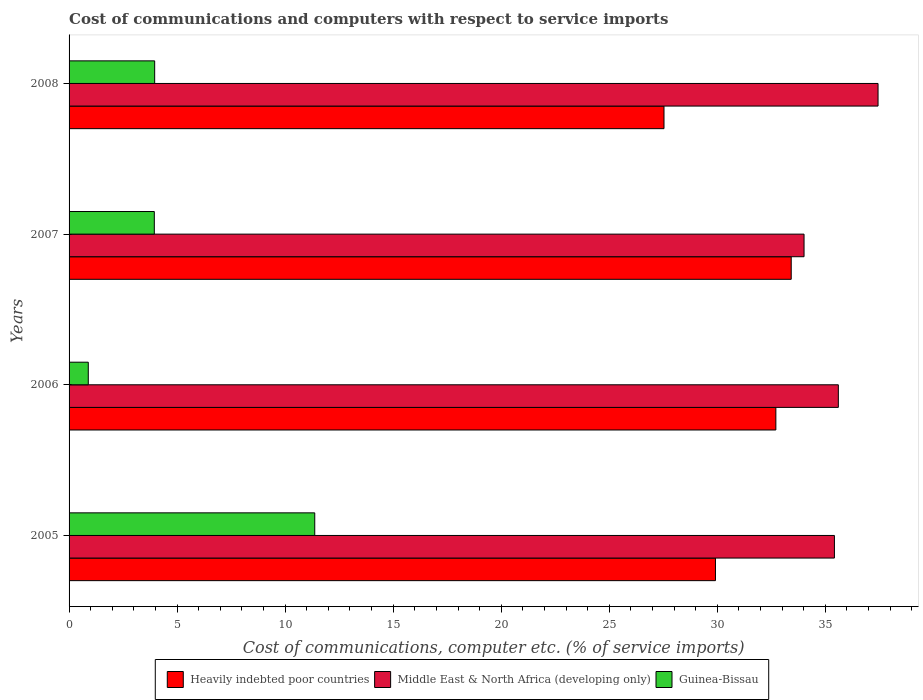How many groups of bars are there?
Provide a short and direct response. 4. Are the number of bars on each tick of the Y-axis equal?
Keep it short and to the point. Yes. How many bars are there on the 1st tick from the top?
Offer a very short reply. 3. In how many cases, is the number of bars for a given year not equal to the number of legend labels?
Provide a short and direct response. 0. What is the cost of communications and computers in Guinea-Bissau in 2007?
Your answer should be very brief. 3.95. Across all years, what is the maximum cost of communications and computers in Middle East & North Africa (developing only)?
Your answer should be very brief. 37.44. Across all years, what is the minimum cost of communications and computers in Guinea-Bissau?
Keep it short and to the point. 0.89. In which year was the cost of communications and computers in Middle East & North Africa (developing only) maximum?
Offer a terse response. 2008. What is the total cost of communications and computers in Heavily indebted poor countries in the graph?
Your response must be concise. 123.58. What is the difference between the cost of communications and computers in Middle East & North Africa (developing only) in 2006 and that in 2008?
Ensure brevity in your answer.  -1.84. What is the difference between the cost of communications and computers in Guinea-Bissau in 2006 and the cost of communications and computers in Heavily indebted poor countries in 2005?
Offer a very short reply. -29.03. What is the average cost of communications and computers in Heavily indebted poor countries per year?
Your answer should be compact. 30.89. In the year 2005, what is the difference between the cost of communications and computers in Guinea-Bissau and cost of communications and computers in Heavily indebted poor countries?
Offer a terse response. -18.54. In how many years, is the cost of communications and computers in Heavily indebted poor countries greater than 23 %?
Provide a short and direct response. 4. What is the ratio of the cost of communications and computers in Heavily indebted poor countries in 2007 to that in 2008?
Make the answer very short. 1.21. Is the cost of communications and computers in Guinea-Bissau in 2005 less than that in 2006?
Ensure brevity in your answer.  No. Is the difference between the cost of communications and computers in Guinea-Bissau in 2006 and 2008 greater than the difference between the cost of communications and computers in Heavily indebted poor countries in 2006 and 2008?
Provide a succinct answer. No. What is the difference between the highest and the second highest cost of communications and computers in Middle East & North Africa (developing only)?
Offer a terse response. 1.84. What is the difference between the highest and the lowest cost of communications and computers in Guinea-Bissau?
Provide a short and direct response. 10.48. Is the sum of the cost of communications and computers in Middle East & North Africa (developing only) in 2005 and 2006 greater than the maximum cost of communications and computers in Heavily indebted poor countries across all years?
Give a very brief answer. Yes. What does the 2nd bar from the top in 2007 represents?
Ensure brevity in your answer.  Middle East & North Africa (developing only). What does the 3rd bar from the bottom in 2005 represents?
Provide a succinct answer. Guinea-Bissau. How many bars are there?
Your answer should be very brief. 12. Are all the bars in the graph horizontal?
Provide a succinct answer. Yes. What is the difference between two consecutive major ticks on the X-axis?
Your answer should be very brief. 5. How many legend labels are there?
Give a very brief answer. 3. How are the legend labels stacked?
Give a very brief answer. Horizontal. What is the title of the graph?
Offer a very short reply. Cost of communications and computers with respect to service imports. Does "Euro area" appear as one of the legend labels in the graph?
Offer a very short reply. No. What is the label or title of the X-axis?
Make the answer very short. Cost of communications, computer etc. (% of service imports). What is the Cost of communications, computer etc. (% of service imports) of Heavily indebted poor countries in 2005?
Your answer should be very brief. 29.91. What is the Cost of communications, computer etc. (% of service imports) in Middle East & North Africa (developing only) in 2005?
Your answer should be compact. 35.42. What is the Cost of communications, computer etc. (% of service imports) in Guinea-Bissau in 2005?
Make the answer very short. 11.37. What is the Cost of communications, computer etc. (% of service imports) in Heavily indebted poor countries in 2006?
Make the answer very short. 32.71. What is the Cost of communications, computer etc. (% of service imports) in Middle East & North Africa (developing only) in 2006?
Offer a terse response. 35.6. What is the Cost of communications, computer etc. (% of service imports) of Guinea-Bissau in 2006?
Ensure brevity in your answer.  0.89. What is the Cost of communications, computer etc. (% of service imports) in Heavily indebted poor countries in 2007?
Your response must be concise. 33.42. What is the Cost of communications, computer etc. (% of service imports) in Middle East & North Africa (developing only) in 2007?
Ensure brevity in your answer.  34.01. What is the Cost of communications, computer etc. (% of service imports) of Guinea-Bissau in 2007?
Offer a very short reply. 3.95. What is the Cost of communications, computer etc. (% of service imports) in Heavily indebted poor countries in 2008?
Give a very brief answer. 27.53. What is the Cost of communications, computer etc. (% of service imports) in Middle East & North Africa (developing only) in 2008?
Your answer should be compact. 37.44. What is the Cost of communications, computer etc. (% of service imports) in Guinea-Bissau in 2008?
Provide a succinct answer. 3.96. Across all years, what is the maximum Cost of communications, computer etc. (% of service imports) in Heavily indebted poor countries?
Give a very brief answer. 33.42. Across all years, what is the maximum Cost of communications, computer etc. (% of service imports) of Middle East & North Africa (developing only)?
Your answer should be compact. 37.44. Across all years, what is the maximum Cost of communications, computer etc. (% of service imports) in Guinea-Bissau?
Your answer should be compact. 11.37. Across all years, what is the minimum Cost of communications, computer etc. (% of service imports) in Heavily indebted poor countries?
Keep it short and to the point. 27.53. Across all years, what is the minimum Cost of communications, computer etc. (% of service imports) of Middle East & North Africa (developing only)?
Your answer should be very brief. 34.01. Across all years, what is the minimum Cost of communications, computer etc. (% of service imports) of Guinea-Bissau?
Make the answer very short. 0.89. What is the total Cost of communications, computer etc. (% of service imports) in Heavily indebted poor countries in the graph?
Your answer should be very brief. 123.58. What is the total Cost of communications, computer etc. (% of service imports) of Middle East & North Africa (developing only) in the graph?
Keep it short and to the point. 142.47. What is the total Cost of communications, computer etc. (% of service imports) in Guinea-Bissau in the graph?
Provide a succinct answer. 20.17. What is the difference between the Cost of communications, computer etc. (% of service imports) of Heavily indebted poor countries in 2005 and that in 2006?
Make the answer very short. -2.79. What is the difference between the Cost of communications, computer etc. (% of service imports) of Middle East & North Africa (developing only) in 2005 and that in 2006?
Offer a very short reply. -0.18. What is the difference between the Cost of communications, computer etc. (% of service imports) of Guinea-Bissau in 2005 and that in 2006?
Ensure brevity in your answer.  10.48. What is the difference between the Cost of communications, computer etc. (% of service imports) in Heavily indebted poor countries in 2005 and that in 2007?
Your answer should be compact. -3.51. What is the difference between the Cost of communications, computer etc. (% of service imports) in Middle East & North Africa (developing only) in 2005 and that in 2007?
Give a very brief answer. 1.41. What is the difference between the Cost of communications, computer etc. (% of service imports) in Guinea-Bissau in 2005 and that in 2007?
Offer a terse response. 7.42. What is the difference between the Cost of communications, computer etc. (% of service imports) of Heavily indebted poor countries in 2005 and that in 2008?
Your answer should be very brief. 2.38. What is the difference between the Cost of communications, computer etc. (% of service imports) in Middle East & North Africa (developing only) in 2005 and that in 2008?
Your answer should be very brief. -2.02. What is the difference between the Cost of communications, computer etc. (% of service imports) of Guinea-Bissau in 2005 and that in 2008?
Offer a terse response. 7.41. What is the difference between the Cost of communications, computer etc. (% of service imports) in Heavily indebted poor countries in 2006 and that in 2007?
Keep it short and to the point. -0.71. What is the difference between the Cost of communications, computer etc. (% of service imports) in Middle East & North Africa (developing only) in 2006 and that in 2007?
Your answer should be very brief. 1.59. What is the difference between the Cost of communications, computer etc. (% of service imports) of Guinea-Bissau in 2006 and that in 2007?
Provide a succinct answer. -3.06. What is the difference between the Cost of communications, computer etc. (% of service imports) of Heavily indebted poor countries in 2006 and that in 2008?
Your response must be concise. 5.18. What is the difference between the Cost of communications, computer etc. (% of service imports) in Middle East & North Africa (developing only) in 2006 and that in 2008?
Offer a terse response. -1.84. What is the difference between the Cost of communications, computer etc. (% of service imports) in Guinea-Bissau in 2006 and that in 2008?
Your response must be concise. -3.07. What is the difference between the Cost of communications, computer etc. (% of service imports) in Heavily indebted poor countries in 2007 and that in 2008?
Keep it short and to the point. 5.89. What is the difference between the Cost of communications, computer etc. (% of service imports) in Middle East & North Africa (developing only) in 2007 and that in 2008?
Give a very brief answer. -3.42. What is the difference between the Cost of communications, computer etc. (% of service imports) in Guinea-Bissau in 2007 and that in 2008?
Provide a short and direct response. -0.02. What is the difference between the Cost of communications, computer etc. (% of service imports) in Heavily indebted poor countries in 2005 and the Cost of communications, computer etc. (% of service imports) in Middle East & North Africa (developing only) in 2006?
Ensure brevity in your answer.  -5.69. What is the difference between the Cost of communications, computer etc. (% of service imports) in Heavily indebted poor countries in 2005 and the Cost of communications, computer etc. (% of service imports) in Guinea-Bissau in 2006?
Ensure brevity in your answer.  29.03. What is the difference between the Cost of communications, computer etc. (% of service imports) of Middle East & North Africa (developing only) in 2005 and the Cost of communications, computer etc. (% of service imports) of Guinea-Bissau in 2006?
Provide a short and direct response. 34.53. What is the difference between the Cost of communications, computer etc. (% of service imports) in Heavily indebted poor countries in 2005 and the Cost of communications, computer etc. (% of service imports) in Middle East & North Africa (developing only) in 2007?
Your answer should be very brief. -4.1. What is the difference between the Cost of communications, computer etc. (% of service imports) of Heavily indebted poor countries in 2005 and the Cost of communications, computer etc. (% of service imports) of Guinea-Bissau in 2007?
Provide a succinct answer. 25.97. What is the difference between the Cost of communications, computer etc. (% of service imports) of Middle East & North Africa (developing only) in 2005 and the Cost of communications, computer etc. (% of service imports) of Guinea-Bissau in 2007?
Your answer should be very brief. 31.48. What is the difference between the Cost of communications, computer etc. (% of service imports) of Heavily indebted poor countries in 2005 and the Cost of communications, computer etc. (% of service imports) of Middle East & North Africa (developing only) in 2008?
Your response must be concise. -7.52. What is the difference between the Cost of communications, computer etc. (% of service imports) in Heavily indebted poor countries in 2005 and the Cost of communications, computer etc. (% of service imports) in Guinea-Bissau in 2008?
Give a very brief answer. 25.95. What is the difference between the Cost of communications, computer etc. (% of service imports) in Middle East & North Africa (developing only) in 2005 and the Cost of communications, computer etc. (% of service imports) in Guinea-Bissau in 2008?
Provide a succinct answer. 31.46. What is the difference between the Cost of communications, computer etc. (% of service imports) of Heavily indebted poor countries in 2006 and the Cost of communications, computer etc. (% of service imports) of Middle East & North Africa (developing only) in 2007?
Give a very brief answer. -1.3. What is the difference between the Cost of communications, computer etc. (% of service imports) of Heavily indebted poor countries in 2006 and the Cost of communications, computer etc. (% of service imports) of Guinea-Bissau in 2007?
Offer a very short reply. 28.76. What is the difference between the Cost of communications, computer etc. (% of service imports) of Middle East & North Africa (developing only) in 2006 and the Cost of communications, computer etc. (% of service imports) of Guinea-Bissau in 2007?
Provide a succinct answer. 31.66. What is the difference between the Cost of communications, computer etc. (% of service imports) in Heavily indebted poor countries in 2006 and the Cost of communications, computer etc. (% of service imports) in Middle East & North Africa (developing only) in 2008?
Keep it short and to the point. -4.73. What is the difference between the Cost of communications, computer etc. (% of service imports) of Heavily indebted poor countries in 2006 and the Cost of communications, computer etc. (% of service imports) of Guinea-Bissau in 2008?
Provide a succinct answer. 28.75. What is the difference between the Cost of communications, computer etc. (% of service imports) in Middle East & North Africa (developing only) in 2006 and the Cost of communications, computer etc. (% of service imports) in Guinea-Bissau in 2008?
Your response must be concise. 31.64. What is the difference between the Cost of communications, computer etc. (% of service imports) of Heavily indebted poor countries in 2007 and the Cost of communications, computer etc. (% of service imports) of Middle East & North Africa (developing only) in 2008?
Your response must be concise. -4.02. What is the difference between the Cost of communications, computer etc. (% of service imports) of Heavily indebted poor countries in 2007 and the Cost of communications, computer etc. (% of service imports) of Guinea-Bissau in 2008?
Give a very brief answer. 29.46. What is the difference between the Cost of communications, computer etc. (% of service imports) of Middle East & North Africa (developing only) in 2007 and the Cost of communications, computer etc. (% of service imports) of Guinea-Bissau in 2008?
Keep it short and to the point. 30.05. What is the average Cost of communications, computer etc. (% of service imports) of Heavily indebted poor countries per year?
Ensure brevity in your answer.  30.89. What is the average Cost of communications, computer etc. (% of service imports) in Middle East & North Africa (developing only) per year?
Ensure brevity in your answer.  35.62. What is the average Cost of communications, computer etc. (% of service imports) of Guinea-Bissau per year?
Your answer should be very brief. 5.04. In the year 2005, what is the difference between the Cost of communications, computer etc. (% of service imports) in Heavily indebted poor countries and Cost of communications, computer etc. (% of service imports) in Middle East & North Africa (developing only)?
Offer a very short reply. -5.51. In the year 2005, what is the difference between the Cost of communications, computer etc. (% of service imports) of Heavily indebted poor countries and Cost of communications, computer etc. (% of service imports) of Guinea-Bissau?
Ensure brevity in your answer.  18.54. In the year 2005, what is the difference between the Cost of communications, computer etc. (% of service imports) of Middle East & North Africa (developing only) and Cost of communications, computer etc. (% of service imports) of Guinea-Bissau?
Ensure brevity in your answer.  24.05. In the year 2006, what is the difference between the Cost of communications, computer etc. (% of service imports) of Heavily indebted poor countries and Cost of communications, computer etc. (% of service imports) of Middle East & North Africa (developing only)?
Make the answer very short. -2.89. In the year 2006, what is the difference between the Cost of communications, computer etc. (% of service imports) in Heavily indebted poor countries and Cost of communications, computer etc. (% of service imports) in Guinea-Bissau?
Give a very brief answer. 31.82. In the year 2006, what is the difference between the Cost of communications, computer etc. (% of service imports) of Middle East & North Africa (developing only) and Cost of communications, computer etc. (% of service imports) of Guinea-Bissau?
Your answer should be compact. 34.71. In the year 2007, what is the difference between the Cost of communications, computer etc. (% of service imports) in Heavily indebted poor countries and Cost of communications, computer etc. (% of service imports) in Middle East & North Africa (developing only)?
Your answer should be very brief. -0.59. In the year 2007, what is the difference between the Cost of communications, computer etc. (% of service imports) of Heavily indebted poor countries and Cost of communications, computer etc. (% of service imports) of Guinea-Bissau?
Provide a short and direct response. 29.48. In the year 2007, what is the difference between the Cost of communications, computer etc. (% of service imports) in Middle East & North Africa (developing only) and Cost of communications, computer etc. (% of service imports) in Guinea-Bissau?
Give a very brief answer. 30.07. In the year 2008, what is the difference between the Cost of communications, computer etc. (% of service imports) of Heavily indebted poor countries and Cost of communications, computer etc. (% of service imports) of Middle East & North Africa (developing only)?
Offer a terse response. -9.91. In the year 2008, what is the difference between the Cost of communications, computer etc. (% of service imports) of Heavily indebted poor countries and Cost of communications, computer etc. (% of service imports) of Guinea-Bissau?
Make the answer very short. 23.57. In the year 2008, what is the difference between the Cost of communications, computer etc. (% of service imports) in Middle East & North Africa (developing only) and Cost of communications, computer etc. (% of service imports) in Guinea-Bissau?
Your answer should be compact. 33.48. What is the ratio of the Cost of communications, computer etc. (% of service imports) in Heavily indebted poor countries in 2005 to that in 2006?
Provide a short and direct response. 0.91. What is the ratio of the Cost of communications, computer etc. (% of service imports) in Guinea-Bissau in 2005 to that in 2006?
Your answer should be compact. 12.79. What is the ratio of the Cost of communications, computer etc. (% of service imports) in Heavily indebted poor countries in 2005 to that in 2007?
Provide a short and direct response. 0.9. What is the ratio of the Cost of communications, computer etc. (% of service imports) in Middle East & North Africa (developing only) in 2005 to that in 2007?
Provide a short and direct response. 1.04. What is the ratio of the Cost of communications, computer etc. (% of service imports) of Guinea-Bissau in 2005 to that in 2007?
Offer a very short reply. 2.88. What is the ratio of the Cost of communications, computer etc. (% of service imports) in Heavily indebted poor countries in 2005 to that in 2008?
Provide a short and direct response. 1.09. What is the ratio of the Cost of communications, computer etc. (% of service imports) of Middle East & North Africa (developing only) in 2005 to that in 2008?
Give a very brief answer. 0.95. What is the ratio of the Cost of communications, computer etc. (% of service imports) of Guinea-Bissau in 2005 to that in 2008?
Provide a succinct answer. 2.87. What is the ratio of the Cost of communications, computer etc. (% of service imports) of Heavily indebted poor countries in 2006 to that in 2007?
Your answer should be compact. 0.98. What is the ratio of the Cost of communications, computer etc. (% of service imports) in Middle East & North Africa (developing only) in 2006 to that in 2007?
Your answer should be compact. 1.05. What is the ratio of the Cost of communications, computer etc. (% of service imports) of Guinea-Bissau in 2006 to that in 2007?
Ensure brevity in your answer.  0.23. What is the ratio of the Cost of communications, computer etc. (% of service imports) of Heavily indebted poor countries in 2006 to that in 2008?
Ensure brevity in your answer.  1.19. What is the ratio of the Cost of communications, computer etc. (% of service imports) of Middle East & North Africa (developing only) in 2006 to that in 2008?
Your answer should be compact. 0.95. What is the ratio of the Cost of communications, computer etc. (% of service imports) in Guinea-Bissau in 2006 to that in 2008?
Offer a very short reply. 0.22. What is the ratio of the Cost of communications, computer etc. (% of service imports) in Heavily indebted poor countries in 2007 to that in 2008?
Your response must be concise. 1.21. What is the ratio of the Cost of communications, computer etc. (% of service imports) in Middle East & North Africa (developing only) in 2007 to that in 2008?
Your answer should be compact. 0.91. What is the difference between the highest and the second highest Cost of communications, computer etc. (% of service imports) of Heavily indebted poor countries?
Provide a short and direct response. 0.71. What is the difference between the highest and the second highest Cost of communications, computer etc. (% of service imports) of Middle East & North Africa (developing only)?
Provide a succinct answer. 1.84. What is the difference between the highest and the second highest Cost of communications, computer etc. (% of service imports) in Guinea-Bissau?
Provide a succinct answer. 7.41. What is the difference between the highest and the lowest Cost of communications, computer etc. (% of service imports) of Heavily indebted poor countries?
Your answer should be very brief. 5.89. What is the difference between the highest and the lowest Cost of communications, computer etc. (% of service imports) of Middle East & North Africa (developing only)?
Your response must be concise. 3.42. What is the difference between the highest and the lowest Cost of communications, computer etc. (% of service imports) of Guinea-Bissau?
Give a very brief answer. 10.48. 